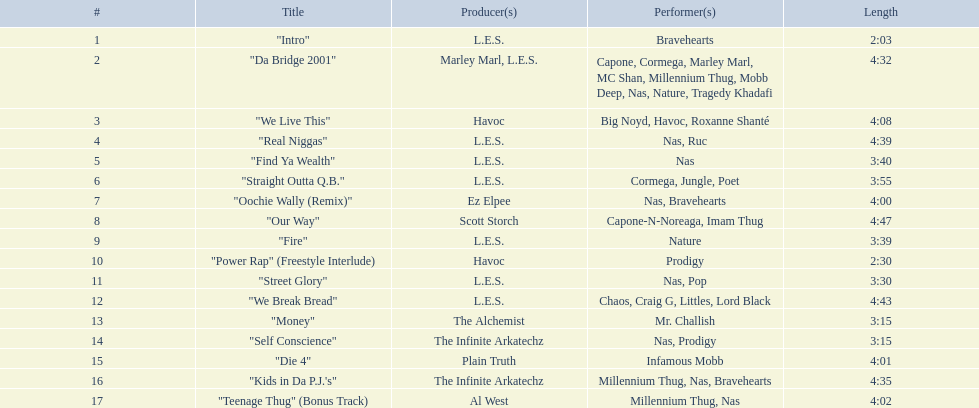What is the length of each melody? 2:03, 4:32, 4:08, 4:39, 3:40, 3:55, 4:00, 4:47, 3:39, 2:30, 3:30, 4:43, 3:15, 3:15, 4:01, 4:35, 4:02. What is the extent of the longest one? 4:47. 